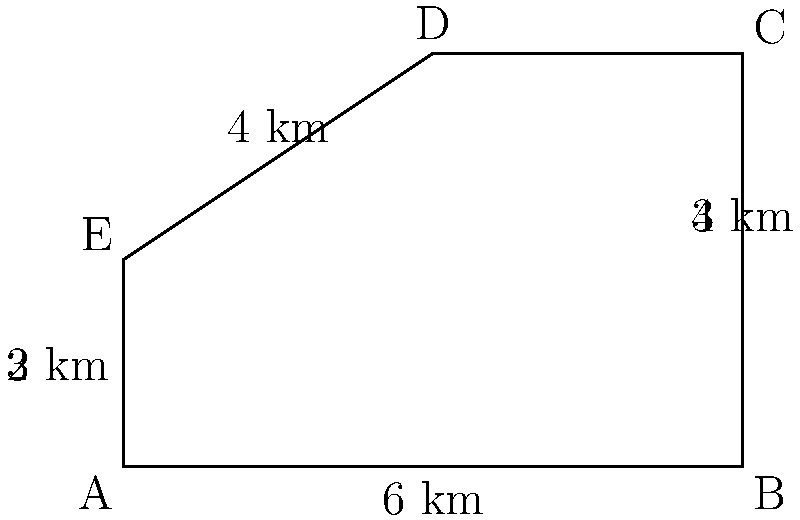As part of your cultural anthropology research on Mardi Gras, you're studying historical parade routes. You've come across an old map of a parade route shaped like an irregular pentagon. The route segments are measured in kilometers. What is the total length of the parade route? To find the total length of the parade route, we need to calculate the perimeter of the irregular pentagon. Let's add up the lengths of all sides:

1. Side AB: 6 km
2. Side BC: 4 km
3. Side CD: 3 km
4. Side DE: 4 km
5. Side EA: 5 km (composed of two segments: 3 km + 2 km)

Now, let's sum up all these lengths:

$$\text{Total length} = 6 + 4 + 3 + 4 + 5 = 22\text{ km}$$

Therefore, the total length of the parade route is 22 km.
Answer: 22 km 